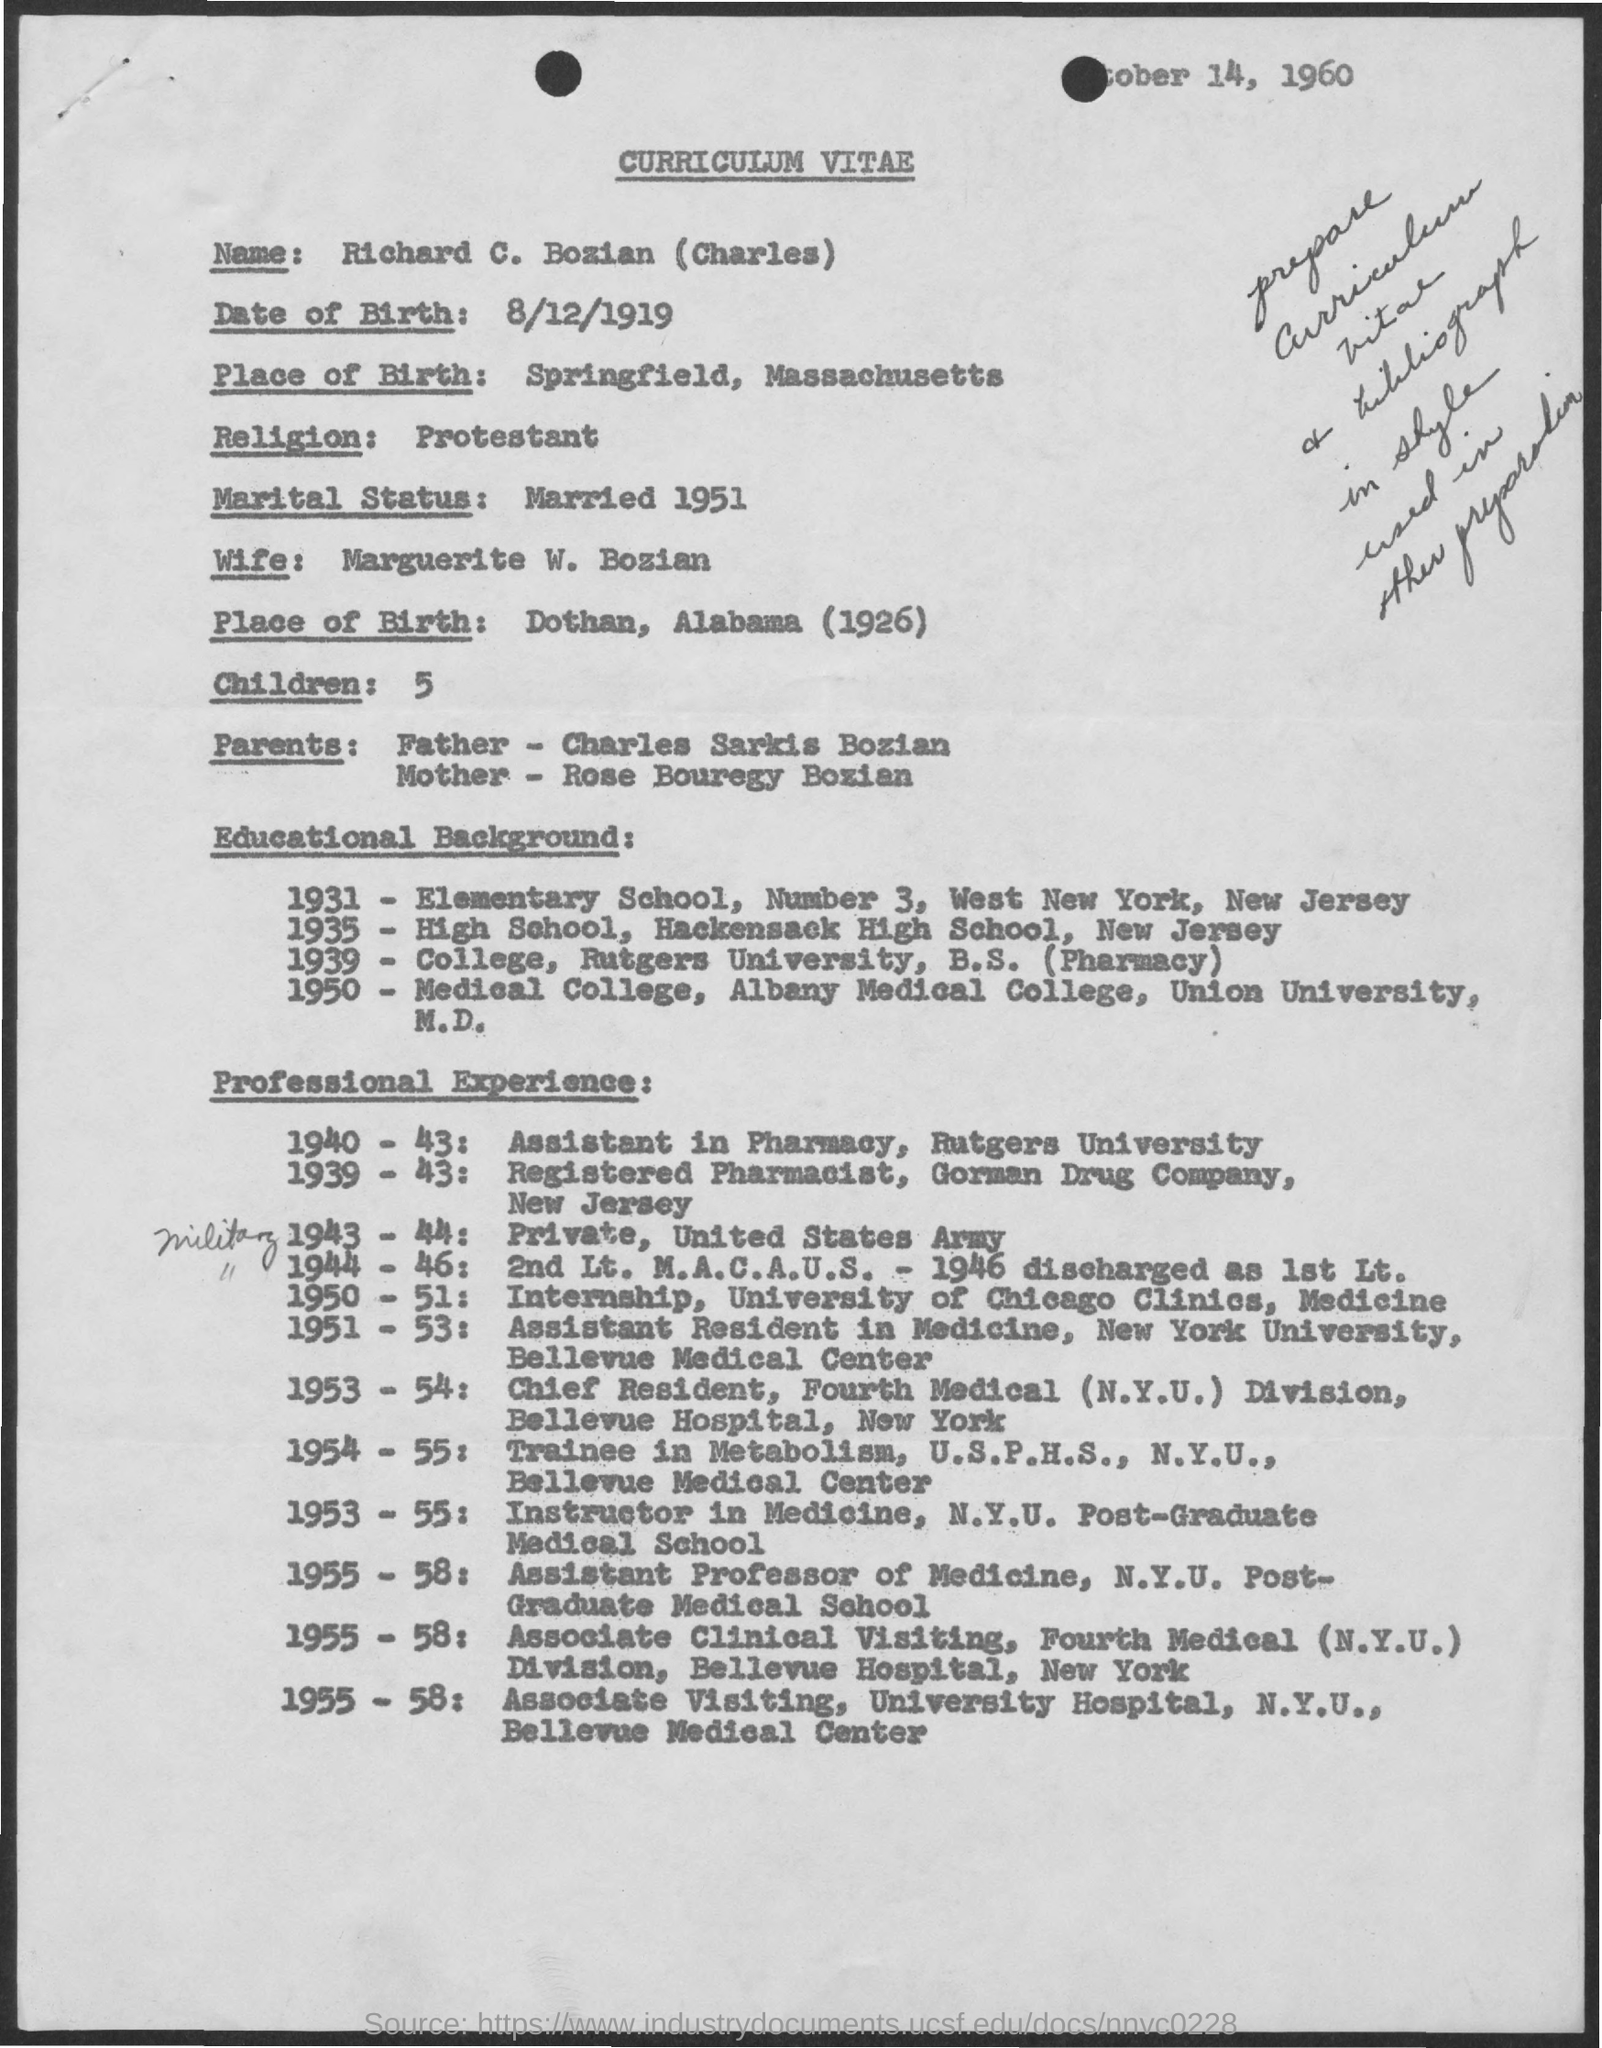Draw attention to some important aspects in this diagram. Richard C. Bozian goes by the alias "Charles. Charles has five children. Charles Sarkis Bozian is the name of Charles' father. The wife of Charles is named Marguerite W. Bozian. Charles is a Protestant. 